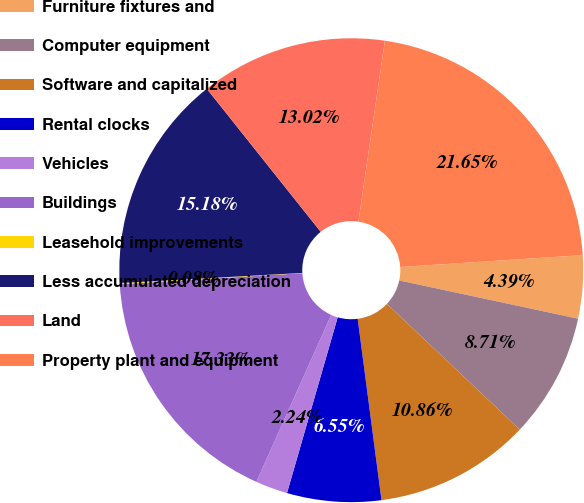Convert chart. <chart><loc_0><loc_0><loc_500><loc_500><pie_chart><fcel>Furniture fixtures and<fcel>Computer equipment<fcel>Software and capitalized<fcel>Rental clocks<fcel>Vehicles<fcel>Buildings<fcel>Leasehold improvements<fcel>Less accumulated depreciation<fcel>Land<fcel>Property plant and equipment<nl><fcel>4.39%<fcel>8.71%<fcel>10.86%<fcel>6.55%<fcel>2.24%<fcel>17.33%<fcel>0.08%<fcel>15.18%<fcel>13.02%<fcel>21.65%<nl></chart> 